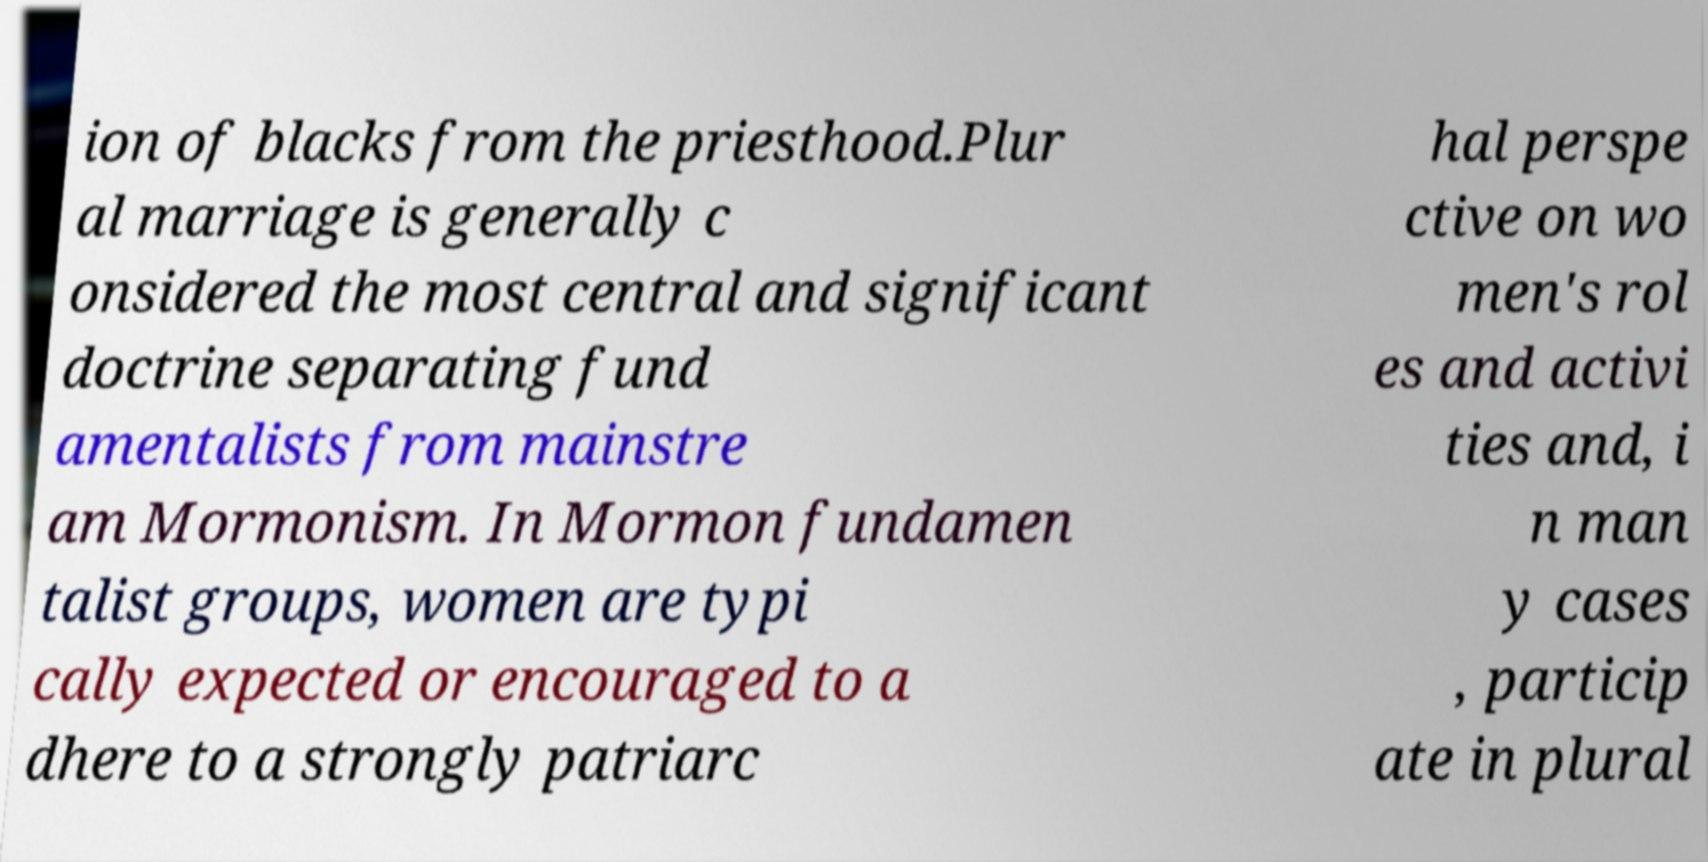Please read and relay the text visible in this image. What does it say? ion of blacks from the priesthood.Plur al marriage is generally c onsidered the most central and significant doctrine separating fund amentalists from mainstre am Mormonism. In Mormon fundamen talist groups, women are typi cally expected or encouraged to a dhere to a strongly patriarc hal perspe ctive on wo men's rol es and activi ties and, i n man y cases , particip ate in plural 